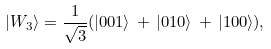<formula> <loc_0><loc_0><loc_500><loc_500>| W _ { 3 } \rangle = \frac { 1 } { \sqrt { 3 } } ( | 0 0 1 \rangle \, + \, | 0 1 0 \rangle \, + \, | 1 0 0 \rangle ) ,</formula> 